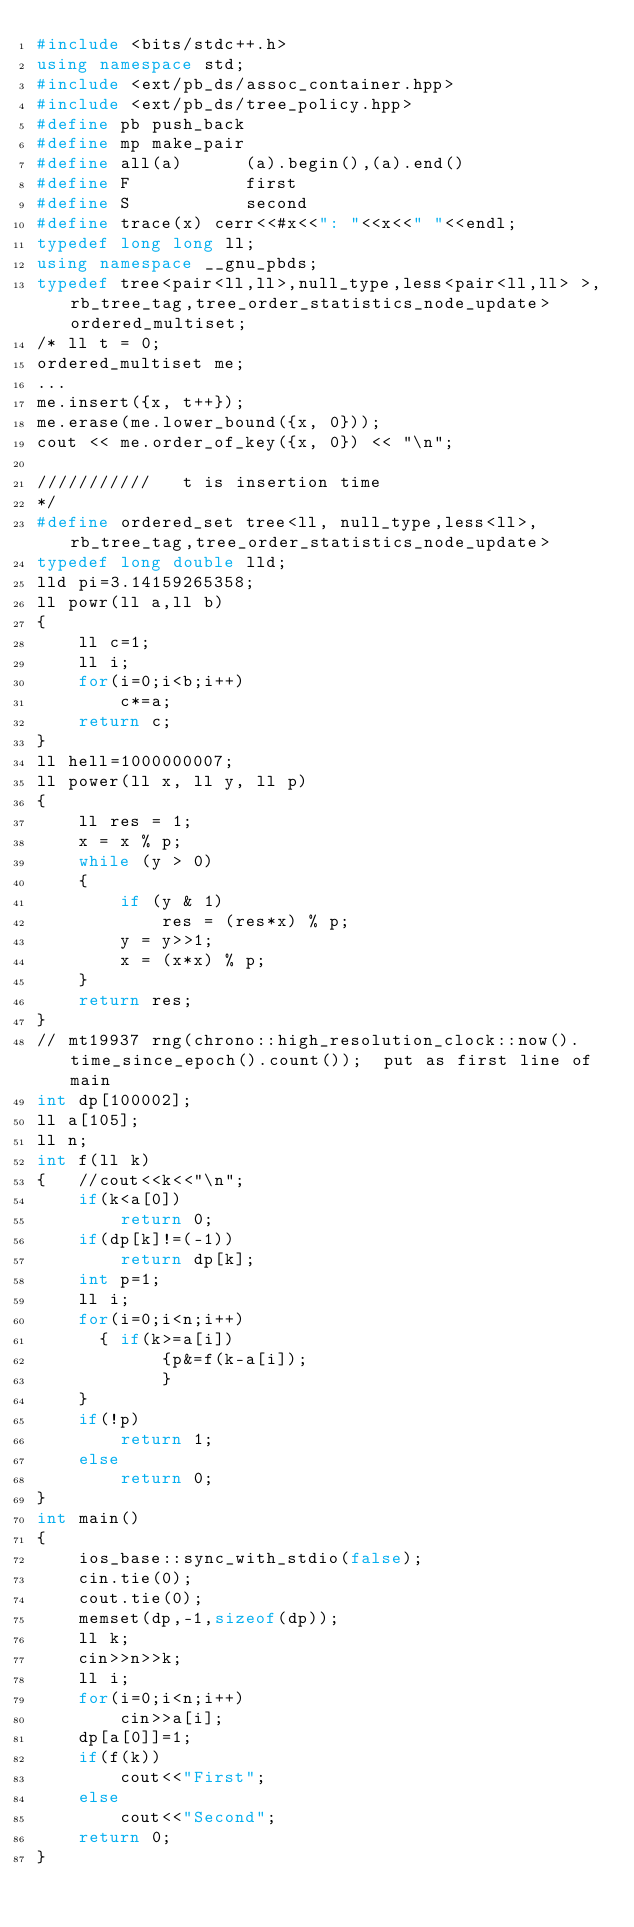Convert code to text. <code><loc_0><loc_0><loc_500><loc_500><_C++_>#include <bits/stdc++.h>
using namespace std;
#include <ext/pb_ds/assoc_container.hpp>
#include <ext/pb_ds/tree_policy.hpp>
#define pb push_back
#define mp make_pair
#define all(a)      (a).begin(),(a).end()
#define F           first
#define S           second
#define trace(x) cerr<<#x<<": "<<x<<" "<<endl;
typedef long long ll;
using namespace __gnu_pbds;
typedef tree<pair<ll,ll>,null_type,less<pair<ll,ll> >,rb_tree_tag,tree_order_statistics_node_update> ordered_multiset;
/* ll t = 0;
ordered_multiset me;
...
me.insert({x, t++});
me.erase(me.lower_bound({x, 0}));
cout << me.order_of_key({x, 0}) << "\n";

///////////   t is insertion time
*/
#define ordered_set tree<ll, null_type,less<ll>, rb_tree_tag,tree_order_statistics_node_update>
typedef long double lld;
lld pi=3.14159265358;
ll powr(ll a,ll b)
{
    ll c=1;
    ll i;
    for(i=0;i<b;i++)
        c*=a;
    return c;
}
ll hell=1000000007;
ll power(ll x, ll y, ll p)
{
    ll res = 1;
    x = x % p;
    while (y > 0)
    {
        if (y & 1)
            res = (res*x) % p;
        y = y>>1;
        x = (x*x) % p;
    }
    return res;
}
// mt19937 rng(chrono::high_resolution_clock::now().time_since_epoch().count());  put as first line of main
int dp[100002];
ll a[105];
ll n;
int f(ll k)
{   //cout<<k<<"\n";
    if(k<a[0])
        return 0;
    if(dp[k]!=(-1))
        return dp[k];
    int p=1;
    ll i;
    for(i=0;i<n;i++)
    	{	if(k>=a[i])
        		{p&=f(k-a[i]);
        		}
    }
    if(!p)
        return 1;
    else
        return 0;
}
int main()
{
    ios_base::sync_with_stdio(false);
    cin.tie(0);
    cout.tie(0);
    memset(dp,-1,sizeof(dp));
    ll k;
    cin>>n>>k;
    ll i;
    for(i=0;i<n;i++)
        cin>>a[i];
    dp[a[0]]=1;
    if(f(k))
        cout<<"First";
    else
        cout<<"Second";
    return 0;
}</code> 